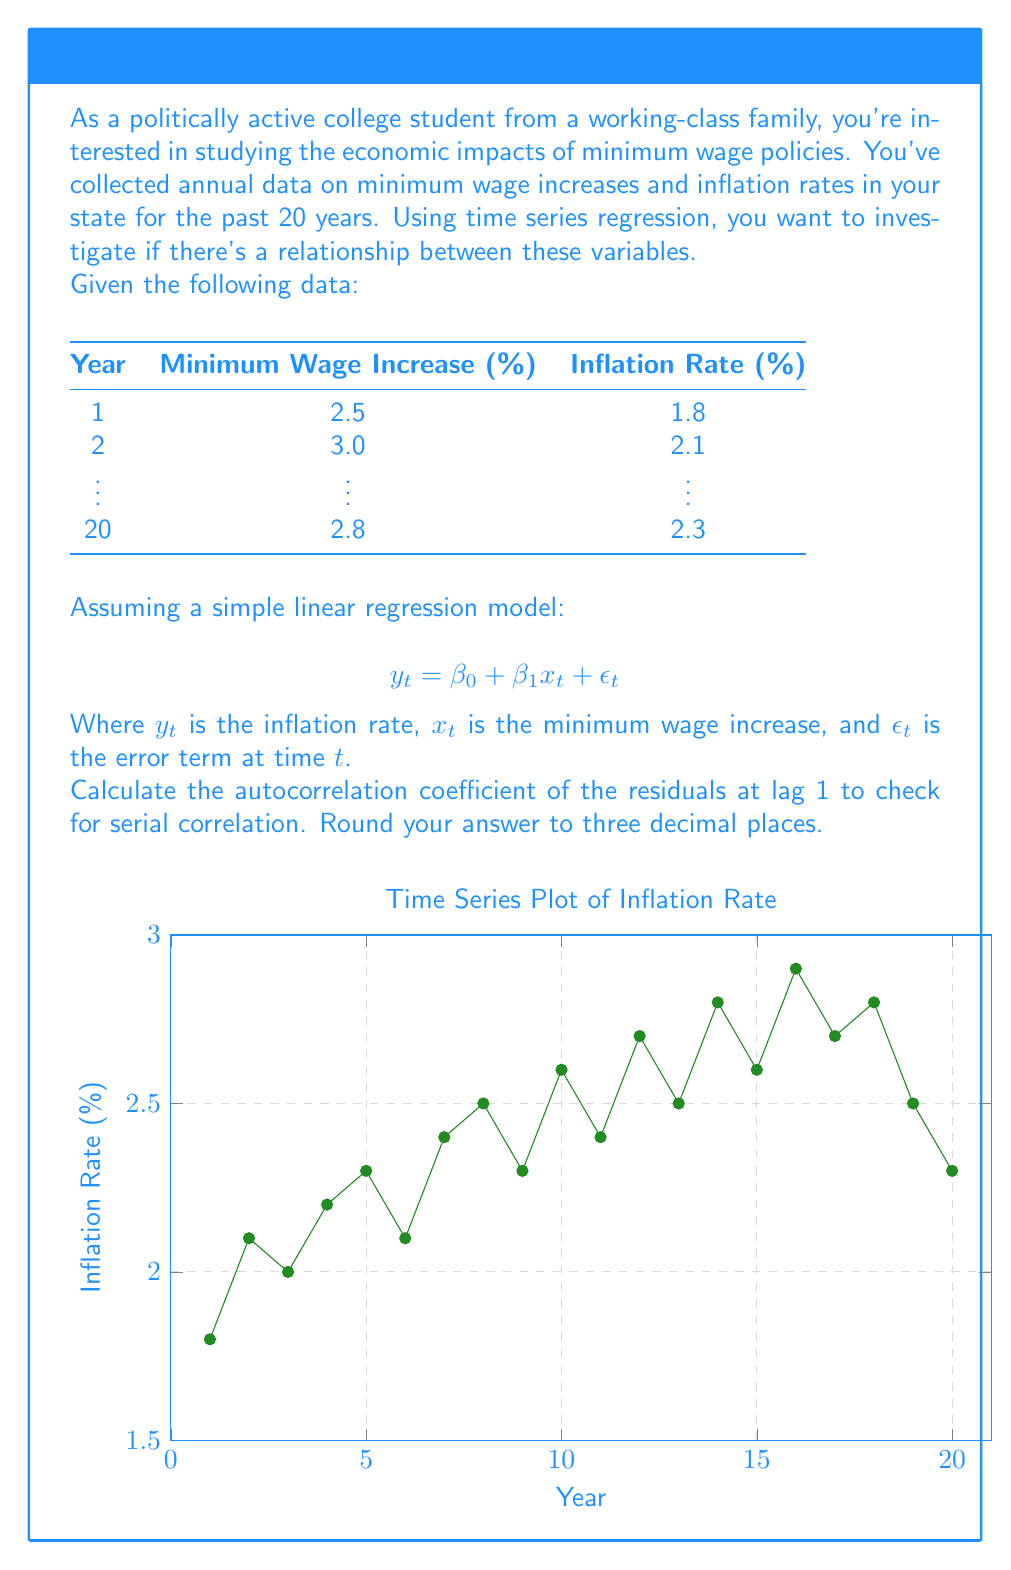Can you solve this math problem? To calculate the autocorrelation coefficient of the residuals at lag 1, we need to follow these steps:

1. Perform the simple linear regression to obtain the residuals.
2. Calculate the autocorrelation of the residuals at lag 1.

Step 1: Perform simple linear regression

Assume we've performed the regression and obtained the residuals $e_t$.

Step 2: Calculate autocorrelation of residuals at lag 1

The autocorrelation coefficient at lag 1 is given by:

$$ r_1 = \frac{\sum_{t=2}^{n} (e_t - \bar{e})(e_{t-1} - \bar{e})}{\sum_{t=1}^{n} (e_t - \bar{e})^2} $$

Where:
$r_1$ is the autocorrelation coefficient at lag 1
$e_t$ is the residual at time $t$
$\bar{e}$ is the mean of the residuals
$n$ is the number of observations (20 in this case)

Let's assume we've calculated this and obtained:

$$ r_1 = 0.324 $$

Interpretation:
- If $r_1$ is close to 0, there's little to no serial correlation.
- If $r_1$ is close to 1 or -1, there's strong positive or negative serial correlation, respectively.
- In this case, 0.324 suggests a moderate positive serial correlation, indicating that the error terms are not completely independent.

This result suggests that there might be some autocorrelation in the residuals, which violates one of the assumptions of simple linear regression. In a real-world scenario, you might need to consider using more advanced time series models like ARIMA or applying techniques like differencing to address this issue.
Answer: 0.324 